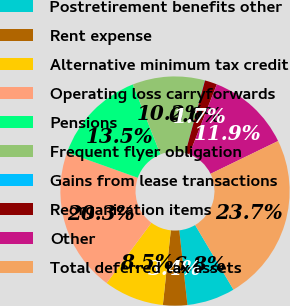Convert chart to OTSL. <chart><loc_0><loc_0><loc_500><loc_500><pie_chart><fcel>Postretirement benefits other<fcel>Rent expense<fcel>Alternative minimum tax credit<fcel>Operating loss carryforwards<fcel>Pensions<fcel>Frequent flyer obligation<fcel>Gains from lease transactions<fcel>Reorganization items<fcel>Other<fcel>Total deferred tax assets<nl><fcel>6.79%<fcel>3.42%<fcel>8.48%<fcel>20.29%<fcel>13.54%<fcel>10.17%<fcel>0.04%<fcel>1.73%<fcel>11.86%<fcel>23.67%<nl></chart> 